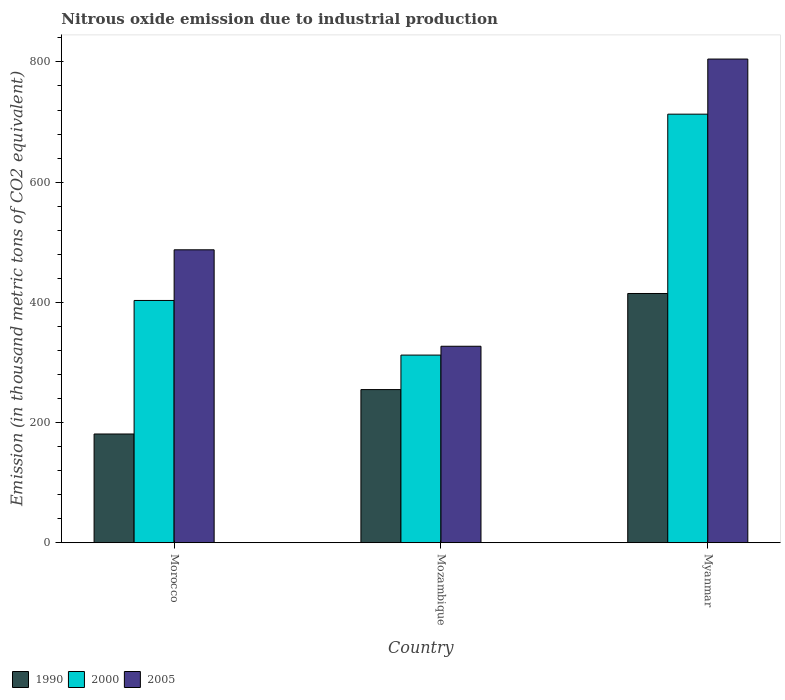How many different coloured bars are there?
Ensure brevity in your answer.  3. How many groups of bars are there?
Your answer should be compact. 3. Are the number of bars per tick equal to the number of legend labels?
Ensure brevity in your answer.  Yes. How many bars are there on the 3rd tick from the left?
Provide a succinct answer. 3. What is the label of the 1st group of bars from the left?
Offer a terse response. Morocco. What is the amount of nitrous oxide emitted in 2000 in Morocco?
Your response must be concise. 403.1. Across all countries, what is the maximum amount of nitrous oxide emitted in 2005?
Your answer should be compact. 804.8. Across all countries, what is the minimum amount of nitrous oxide emitted in 2000?
Your response must be concise. 312.2. In which country was the amount of nitrous oxide emitted in 2000 maximum?
Offer a very short reply. Myanmar. In which country was the amount of nitrous oxide emitted in 2005 minimum?
Make the answer very short. Mozambique. What is the total amount of nitrous oxide emitted in 1990 in the graph?
Offer a terse response. 850.4. What is the difference between the amount of nitrous oxide emitted in 1990 in Morocco and that in Mozambique?
Provide a succinct answer. -73.9. What is the difference between the amount of nitrous oxide emitted in 2005 in Morocco and the amount of nitrous oxide emitted in 2000 in Mozambique?
Give a very brief answer. 175.2. What is the average amount of nitrous oxide emitted in 1990 per country?
Make the answer very short. 283.47. What is the difference between the amount of nitrous oxide emitted of/in 2000 and amount of nitrous oxide emitted of/in 2005 in Morocco?
Your answer should be compact. -84.3. In how many countries, is the amount of nitrous oxide emitted in 2005 greater than 640 thousand metric tons?
Ensure brevity in your answer.  1. What is the ratio of the amount of nitrous oxide emitted in 2005 in Morocco to that in Myanmar?
Your response must be concise. 0.61. Is the difference between the amount of nitrous oxide emitted in 2000 in Morocco and Myanmar greater than the difference between the amount of nitrous oxide emitted in 2005 in Morocco and Myanmar?
Your answer should be compact. Yes. What is the difference between the highest and the second highest amount of nitrous oxide emitted in 2005?
Your answer should be very brief. 477.9. What is the difference between the highest and the lowest amount of nitrous oxide emitted in 2005?
Ensure brevity in your answer.  477.9. In how many countries, is the amount of nitrous oxide emitted in 2000 greater than the average amount of nitrous oxide emitted in 2000 taken over all countries?
Offer a terse response. 1. Is the sum of the amount of nitrous oxide emitted in 2000 in Morocco and Mozambique greater than the maximum amount of nitrous oxide emitted in 1990 across all countries?
Your answer should be very brief. Yes. What does the 3rd bar from the right in Myanmar represents?
Your answer should be compact. 1990. Is it the case that in every country, the sum of the amount of nitrous oxide emitted in 2005 and amount of nitrous oxide emitted in 2000 is greater than the amount of nitrous oxide emitted in 1990?
Offer a very short reply. Yes. How many bars are there?
Your answer should be compact. 9. How many countries are there in the graph?
Your answer should be compact. 3. What is the difference between two consecutive major ticks on the Y-axis?
Your answer should be compact. 200. Are the values on the major ticks of Y-axis written in scientific E-notation?
Offer a very short reply. No. Does the graph contain any zero values?
Your answer should be very brief. No. Where does the legend appear in the graph?
Your answer should be very brief. Bottom left. How many legend labels are there?
Provide a succinct answer. 3. What is the title of the graph?
Your answer should be very brief. Nitrous oxide emission due to industrial production. Does "1973" appear as one of the legend labels in the graph?
Your answer should be compact. No. What is the label or title of the Y-axis?
Your response must be concise. Emission (in thousand metric tons of CO2 equivalent). What is the Emission (in thousand metric tons of CO2 equivalent) of 1990 in Morocco?
Your response must be concise. 180.9. What is the Emission (in thousand metric tons of CO2 equivalent) of 2000 in Morocco?
Offer a terse response. 403.1. What is the Emission (in thousand metric tons of CO2 equivalent) in 2005 in Morocco?
Keep it short and to the point. 487.4. What is the Emission (in thousand metric tons of CO2 equivalent) in 1990 in Mozambique?
Offer a terse response. 254.8. What is the Emission (in thousand metric tons of CO2 equivalent) in 2000 in Mozambique?
Keep it short and to the point. 312.2. What is the Emission (in thousand metric tons of CO2 equivalent) in 2005 in Mozambique?
Ensure brevity in your answer.  326.9. What is the Emission (in thousand metric tons of CO2 equivalent) in 1990 in Myanmar?
Offer a terse response. 414.7. What is the Emission (in thousand metric tons of CO2 equivalent) of 2000 in Myanmar?
Offer a very short reply. 713.1. What is the Emission (in thousand metric tons of CO2 equivalent) of 2005 in Myanmar?
Your answer should be very brief. 804.8. Across all countries, what is the maximum Emission (in thousand metric tons of CO2 equivalent) in 1990?
Offer a very short reply. 414.7. Across all countries, what is the maximum Emission (in thousand metric tons of CO2 equivalent) in 2000?
Offer a very short reply. 713.1. Across all countries, what is the maximum Emission (in thousand metric tons of CO2 equivalent) in 2005?
Keep it short and to the point. 804.8. Across all countries, what is the minimum Emission (in thousand metric tons of CO2 equivalent) of 1990?
Your answer should be very brief. 180.9. Across all countries, what is the minimum Emission (in thousand metric tons of CO2 equivalent) in 2000?
Provide a short and direct response. 312.2. Across all countries, what is the minimum Emission (in thousand metric tons of CO2 equivalent) of 2005?
Make the answer very short. 326.9. What is the total Emission (in thousand metric tons of CO2 equivalent) in 1990 in the graph?
Give a very brief answer. 850.4. What is the total Emission (in thousand metric tons of CO2 equivalent) of 2000 in the graph?
Give a very brief answer. 1428.4. What is the total Emission (in thousand metric tons of CO2 equivalent) of 2005 in the graph?
Offer a very short reply. 1619.1. What is the difference between the Emission (in thousand metric tons of CO2 equivalent) of 1990 in Morocco and that in Mozambique?
Your answer should be compact. -73.9. What is the difference between the Emission (in thousand metric tons of CO2 equivalent) of 2000 in Morocco and that in Mozambique?
Give a very brief answer. 90.9. What is the difference between the Emission (in thousand metric tons of CO2 equivalent) of 2005 in Morocco and that in Mozambique?
Offer a terse response. 160.5. What is the difference between the Emission (in thousand metric tons of CO2 equivalent) of 1990 in Morocco and that in Myanmar?
Keep it short and to the point. -233.8. What is the difference between the Emission (in thousand metric tons of CO2 equivalent) of 2000 in Morocco and that in Myanmar?
Offer a very short reply. -310. What is the difference between the Emission (in thousand metric tons of CO2 equivalent) in 2005 in Morocco and that in Myanmar?
Offer a terse response. -317.4. What is the difference between the Emission (in thousand metric tons of CO2 equivalent) of 1990 in Mozambique and that in Myanmar?
Ensure brevity in your answer.  -159.9. What is the difference between the Emission (in thousand metric tons of CO2 equivalent) in 2000 in Mozambique and that in Myanmar?
Make the answer very short. -400.9. What is the difference between the Emission (in thousand metric tons of CO2 equivalent) in 2005 in Mozambique and that in Myanmar?
Provide a succinct answer. -477.9. What is the difference between the Emission (in thousand metric tons of CO2 equivalent) in 1990 in Morocco and the Emission (in thousand metric tons of CO2 equivalent) in 2000 in Mozambique?
Offer a terse response. -131.3. What is the difference between the Emission (in thousand metric tons of CO2 equivalent) of 1990 in Morocco and the Emission (in thousand metric tons of CO2 equivalent) of 2005 in Mozambique?
Ensure brevity in your answer.  -146. What is the difference between the Emission (in thousand metric tons of CO2 equivalent) of 2000 in Morocco and the Emission (in thousand metric tons of CO2 equivalent) of 2005 in Mozambique?
Keep it short and to the point. 76.2. What is the difference between the Emission (in thousand metric tons of CO2 equivalent) of 1990 in Morocco and the Emission (in thousand metric tons of CO2 equivalent) of 2000 in Myanmar?
Provide a short and direct response. -532.2. What is the difference between the Emission (in thousand metric tons of CO2 equivalent) of 1990 in Morocco and the Emission (in thousand metric tons of CO2 equivalent) of 2005 in Myanmar?
Offer a terse response. -623.9. What is the difference between the Emission (in thousand metric tons of CO2 equivalent) in 2000 in Morocco and the Emission (in thousand metric tons of CO2 equivalent) in 2005 in Myanmar?
Offer a terse response. -401.7. What is the difference between the Emission (in thousand metric tons of CO2 equivalent) of 1990 in Mozambique and the Emission (in thousand metric tons of CO2 equivalent) of 2000 in Myanmar?
Offer a very short reply. -458.3. What is the difference between the Emission (in thousand metric tons of CO2 equivalent) in 1990 in Mozambique and the Emission (in thousand metric tons of CO2 equivalent) in 2005 in Myanmar?
Your answer should be very brief. -550. What is the difference between the Emission (in thousand metric tons of CO2 equivalent) of 2000 in Mozambique and the Emission (in thousand metric tons of CO2 equivalent) of 2005 in Myanmar?
Offer a very short reply. -492.6. What is the average Emission (in thousand metric tons of CO2 equivalent) of 1990 per country?
Keep it short and to the point. 283.47. What is the average Emission (in thousand metric tons of CO2 equivalent) in 2000 per country?
Offer a terse response. 476.13. What is the average Emission (in thousand metric tons of CO2 equivalent) of 2005 per country?
Provide a short and direct response. 539.7. What is the difference between the Emission (in thousand metric tons of CO2 equivalent) in 1990 and Emission (in thousand metric tons of CO2 equivalent) in 2000 in Morocco?
Your response must be concise. -222.2. What is the difference between the Emission (in thousand metric tons of CO2 equivalent) in 1990 and Emission (in thousand metric tons of CO2 equivalent) in 2005 in Morocco?
Give a very brief answer. -306.5. What is the difference between the Emission (in thousand metric tons of CO2 equivalent) of 2000 and Emission (in thousand metric tons of CO2 equivalent) of 2005 in Morocco?
Provide a succinct answer. -84.3. What is the difference between the Emission (in thousand metric tons of CO2 equivalent) of 1990 and Emission (in thousand metric tons of CO2 equivalent) of 2000 in Mozambique?
Your answer should be very brief. -57.4. What is the difference between the Emission (in thousand metric tons of CO2 equivalent) of 1990 and Emission (in thousand metric tons of CO2 equivalent) of 2005 in Mozambique?
Provide a succinct answer. -72.1. What is the difference between the Emission (in thousand metric tons of CO2 equivalent) in 2000 and Emission (in thousand metric tons of CO2 equivalent) in 2005 in Mozambique?
Your response must be concise. -14.7. What is the difference between the Emission (in thousand metric tons of CO2 equivalent) in 1990 and Emission (in thousand metric tons of CO2 equivalent) in 2000 in Myanmar?
Your response must be concise. -298.4. What is the difference between the Emission (in thousand metric tons of CO2 equivalent) of 1990 and Emission (in thousand metric tons of CO2 equivalent) of 2005 in Myanmar?
Make the answer very short. -390.1. What is the difference between the Emission (in thousand metric tons of CO2 equivalent) in 2000 and Emission (in thousand metric tons of CO2 equivalent) in 2005 in Myanmar?
Your response must be concise. -91.7. What is the ratio of the Emission (in thousand metric tons of CO2 equivalent) in 1990 in Morocco to that in Mozambique?
Offer a very short reply. 0.71. What is the ratio of the Emission (in thousand metric tons of CO2 equivalent) of 2000 in Morocco to that in Mozambique?
Make the answer very short. 1.29. What is the ratio of the Emission (in thousand metric tons of CO2 equivalent) in 2005 in Morocco to that in Mozambique?
Offer a terse response. 1.49. What is the ratio of the Emission (in thousand metric tons of CO2 equivalent) of 1990 in Morocco to that in Myanmar?
Offer a very short reply. 0.44. What is the ratio of the Emission (in thousand metric tons of CO2 equivalent) of 2000 in Morocco to that in Myanmar?
Make the answer very short. 0.57. What is the ratio of the Emission (in thousand metric tons of CO2 equivalent) of 2005 in Morocco to that in Myanmar?
Ensure brevity in your answer.  0.61. What is the ratio of the Emission (in thousand metric tons of CO2 equivalent) in 1990 in Mozambique to that in Myanmar?
Your answer should be very brief. 0.61. What is the ratio of the Emission (in thousand metric tons of CO2 equivalent) in 2000 in Mozambique to that in Myanmar?
Your answer should be very brief. 0.44. What is the ratio of the Emission (in thousand metric tons of CO2 equivalent) of 2005 in Mozambique to that in Myanmar?
Provide a succinct answer. 0.41. What is the difference between the highest and the second highest Emission (in thousand metric tons of CO2 equivalent) of 1990?
Give a very brief answer. 159.9. What is the difference between the highest and the second highest Emission (in thousand metric tons of CO2 equivalent) of 2000?
Make the answer very short. 310. What is the difference between the highest and the second highest Emission (in thousand metric tons of CO2 equivalent) in 2005?
Provide a short and direct response. 317.4. What is the difference between the highest and the lowest Emission (in thousand metric tons of CO2 equivalent) of 1990?
Provide a short and direct response. 233.8. What is the difference between the highest and the lowest Emission (in thousand metric tons of CO2 equivalent) of 2000?
Provide a short and direct response. 400.9. What is the difference between the highest and the lowest Emission (in thousand metric tons of CO2 equivalent) of 2005?
Offer a terse response. 477.9. 